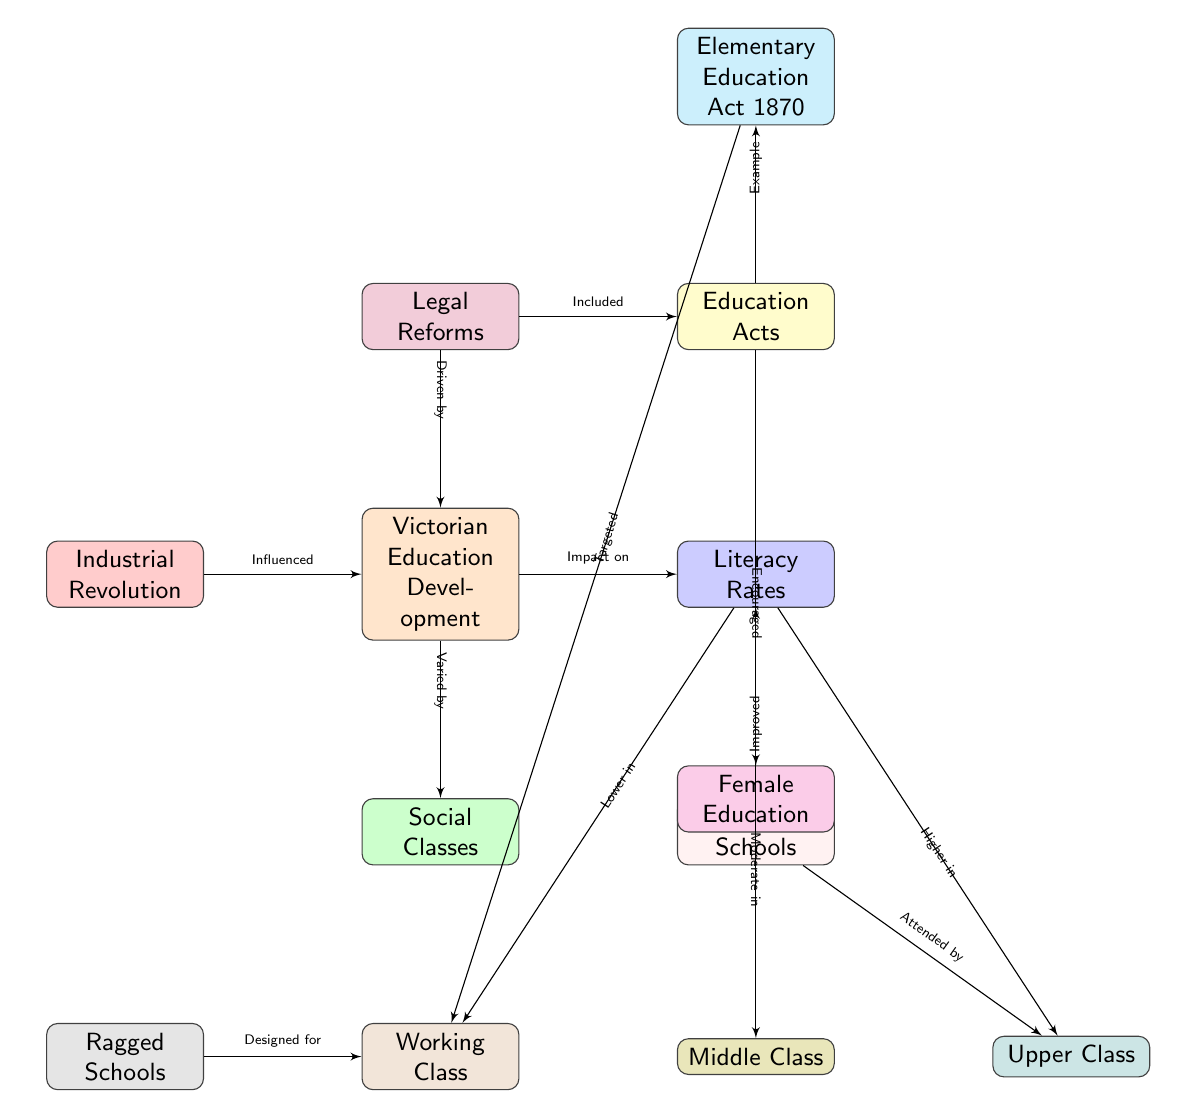What does the diagram mainly illustrate? The diagram illustrates the development of the Victorian education systems and their impact on literacy rates across different social classes.
Answer: Victorian education development How many main categories are there in the diagram? The diagram contains five main categories: Victorian Education Development, Literacy Rates, Social Classes, Industrial Revolution, and Legal Reforms.
Answer: Five Which node is connected to both Legal Reforms and Education Acts? The node "Victorian Education Development" is connected to both "Legal Reforms" (driven by) and "Education Acts" (included).
Answer: Victorian Education Development What is the impact of education on the working class literacy rates? According to the diagram, literacy rates were lower in the working class, indicating a negative impact due to limited educational access.
Answer: Lower How did the Elementary Education Act 1870 target specific social classes? The Elementary Education Act 1870 primarily targeted the working class, as indicated by the connecting edge labeled "targeted."
Answer: Working class What impact did the Industrial Revolution have on Victorian education? The Industrial Revolution influenced the development of the Victorian education system, creating a need for better literacy among workers.
Answer: Influenced What type of schools were designed specifically for the working class? Ragged Schools were designed specifically for the working class, as shown in the diagram.
Answer: Ragged Schools Which class had the highest literacy rates according to the diagram? The Upper Class had the highest literacy rates, as indicated by the edge stating it was "higher in" that social class.
Answer: Higher How did public schools relate to the upper class? The diagram states that public schools were attended by the upper class, showing a direct connection between them.
Answer: Attended by What effect did female education have on overall literacy rates? The diagram indicates that female education improved overall literacy rates, demonstrating its positive impact.
Answer: Improved 